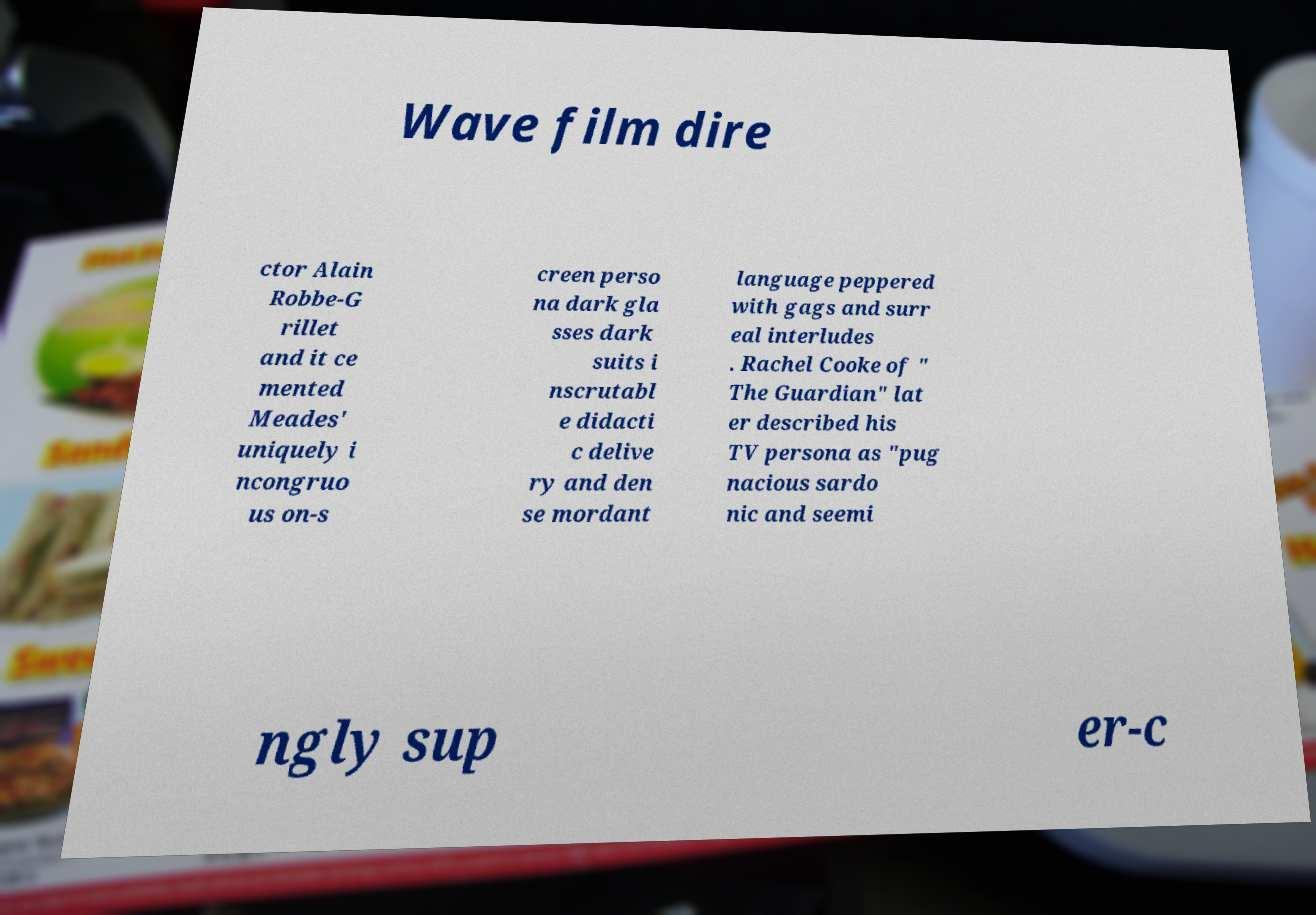Can you read and provide the text displayed in the image?This photo seems to have some interesting text. Can you extract and type it out for me? Wave film dire ctor Alain Robbe-G rillet and it ce mented Meades' uniquely i ncongruo us on-s creen perso na dark gla sses dark suits i nscrutabl e didacti c delive ry and den se mordant language peppered with gags and surr eal interludes . Rachel Cooke of " The Guardian" lat er described his TV persona as "pug nacious sardo nic and seemi ngly sup er-c 